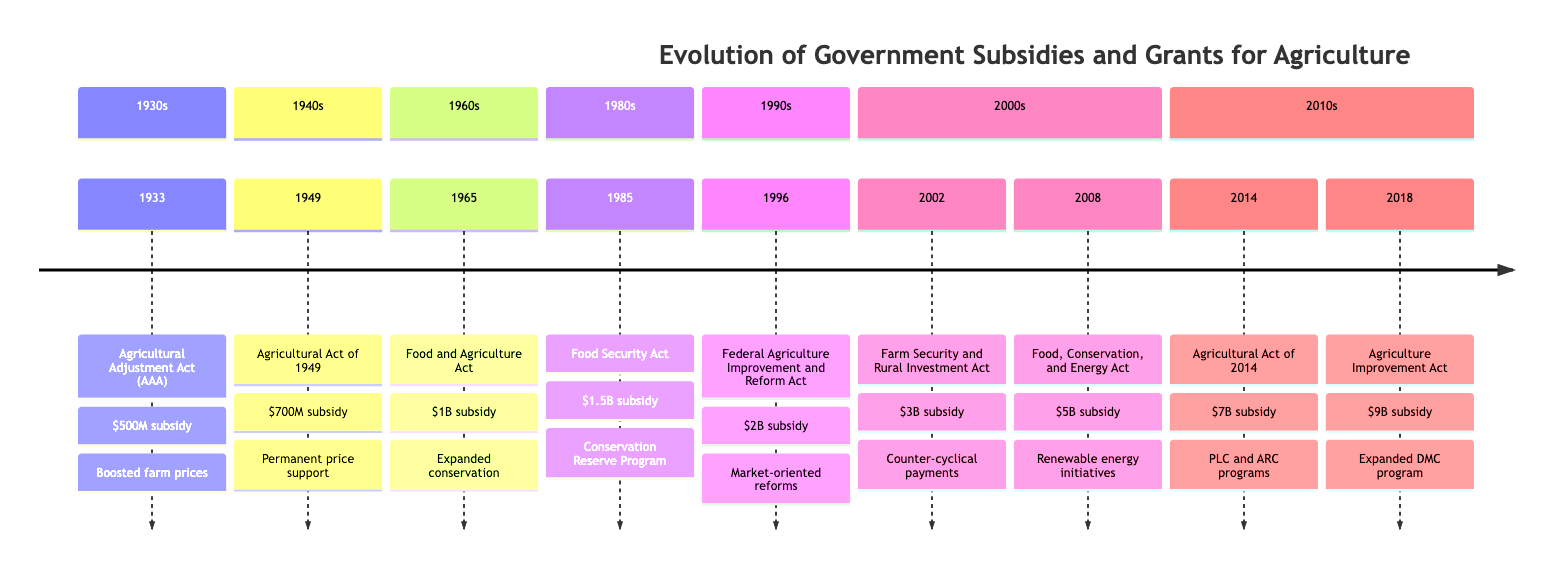What year was the Agricultural Adjustment Act enacted? The diagram indicates that the Agricultural Adjustment Act (AAA) was enacted in the year 1933, as shown prominently in the first section of the timeline.
Answer: 1933 What was the subsidy amount for the Food Security Act in 1985? The Food Security Act is displayed on the timeline with a subsidy amount of 1.5 billion USD in the section for the 1980s, making it easy to locate the relevant information.
Answer: 1.5 billion USD Which act introduced the Dairy Margin Coverage program? The Dairy Margin Coverage program was expanded as per the Agricultural Improvement Act, which is noted in the section for the 2010s, specifically in the year 2018 on the timeline.
Answer: Agricultural Improvement Act What was the cumulative subsidy amount from 1933 to 2014? To calculate the cumulative amount, one would sum the specified subsidy amounts for each act listed from 1933 to 2014: 500 million USD + 700 million USD + 1 billion USD + 1.5 billion USD + 2 billion USD + 3 billion USD + 5 billion USD + 7 billion USD = 21.7 billion USD total.
Answer: 21.7 billion USD In which decade was the Federal Agriculture Improvement and Reform Act passed? The Federal Agriculture Improvement and Reform Act (FAIR) is specifically located in the section for the 1990s in the timeline, indicating it was enacted in that decade.
Answer: 1990s What significant change occurred in the Agricultural Act of 2014? The Agricultural Act of 2014 is noted for eliminating direct payments and introducing new programs (PLC and ARC), which signifies a major policy shift and is highlighted in the respective section of the timeline.
Answer: Eliminated direct payments Which policy had the highest subsidy amount and what was it? The question requires examining the subsidy amounts across all policies in the timeline; the largest subsidy amount is clearly stated as 9 billion USD associated with the Agriculture Improvement Act of 2018.
Answer: Agriculture Improvement Act, 9 billion USD How many policies were introduced between 2002 and 2018? In the timeline, there are two policies indicated between 2002 and 2018: the Farm Security and Rural Investment Act and the Agriculture Improvement Act, making it straightforward to count each occurrence in the respective sections.
Answer: 2 